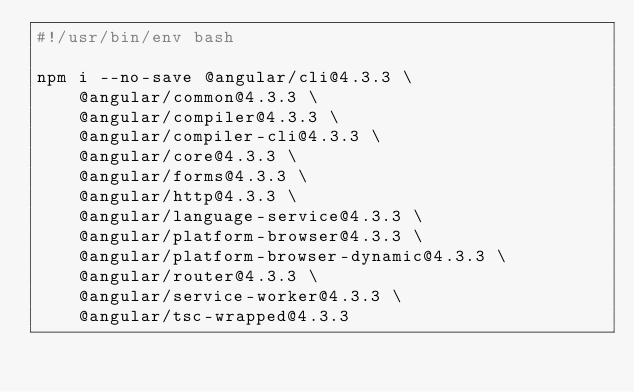<code> <loc_0><loc_0><loc_500><loc_500><_Bash_>#!/usr/bin/env bash

npm i --no-save @angular/cli@4.3.3 \
    @angular/common@4.3.3 \
    @angular/compiler@4.3.3 \
    @angular/compiler-cli@4.3.3 \
    @angular/core@4.3.3 \
    @angular/forms@4.3.3 \
    @angular/http@4.3.3 \
    @angular/language-service@4.3.3 \
    @angular/platform-browser@4.3.3 \
    @angular/platform-browser-dynamic@4.3.3 \
    @angular/router@4.3.3 \
    @angular/service-worker@4.3.3 \
    @angular/tsc-wrapped@4.3.3
</code> 